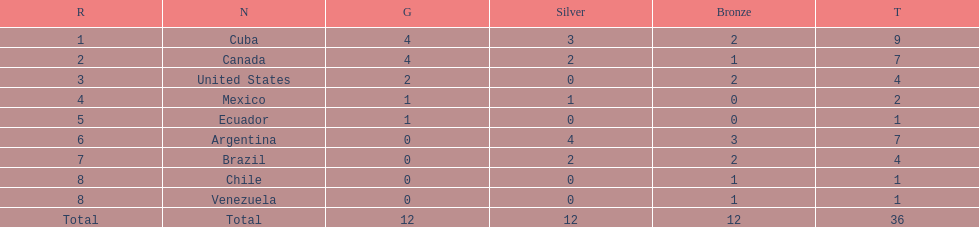How many total medals did argentina win? 7. 